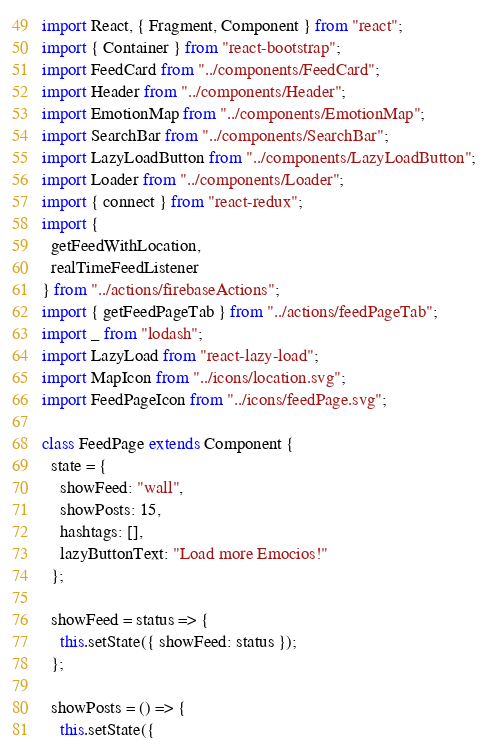Convert code to text. <code><loc_0><loc_0><loc_500><loc_500><_JavaScript_>import React, { Fragment, Component } from "react";
import { Container } from "react-bootstrap";
import FeedCard from "../components/FeedCard";
import Header from "../components/Header";
import EmotionMap from "../components/EmotionMap";
import SearchBar from "../components/SearchBar";
import LazyLoadButton from "../components/LazyLoadButton";
import Loader from "../components/Loader";
import { connect } from "react-redux";
import {
  getFeedWithLocation,
  realTimeFeedListener
} from "../actions/firebaseActions";
import { getFeedPageTab } from "../actions/feedPageTab";
import _ from "lodash";
import LazyLoad from "react-lazy-load";
import MapIcon from "../icons/location.svg";
import FeedPageIcon from "../icons/feedPage.svg";

class FeedPage extends Component {
  state = {
    showFeed: "wall",
    showPosts: 15,
    hashtags: [],
    lazyButtonText: "Load more Emocios!"
  };

  showFeed = status => {
    this.setState({ showFeed: status });
  };

  showPosts = () => {
    this.setState({</code> 